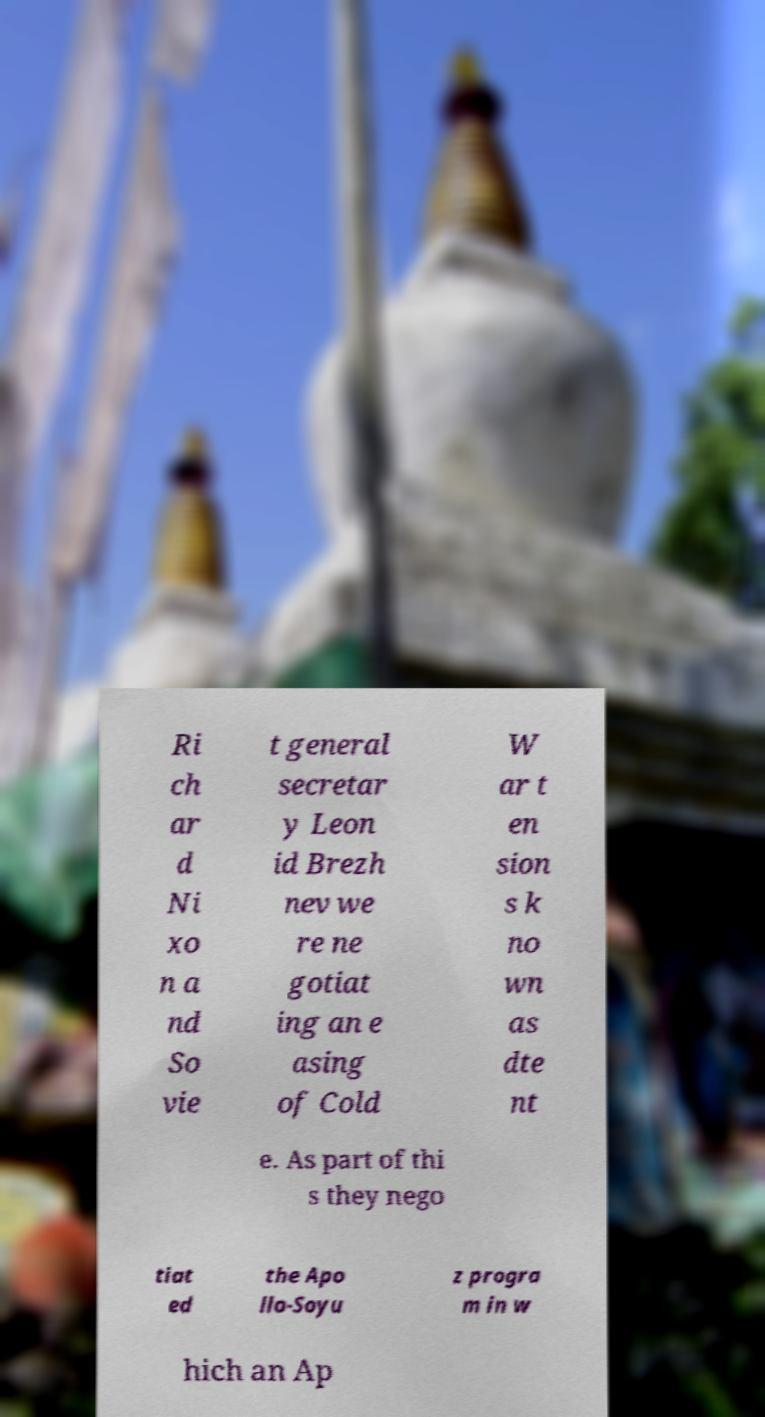What messages or text are displayed in this image? I need them in a readable, typed format. Ri ch ar d Ni xo n a nd So vie t general secretar y Leon id Brezh nev we re ne gotiat ing an e asing of Cold W ar t en sion s k no wn as dte nt e. As part of thi s they nego tiat ed the Apo llo-Soyu z progra m in w hich an Ap 